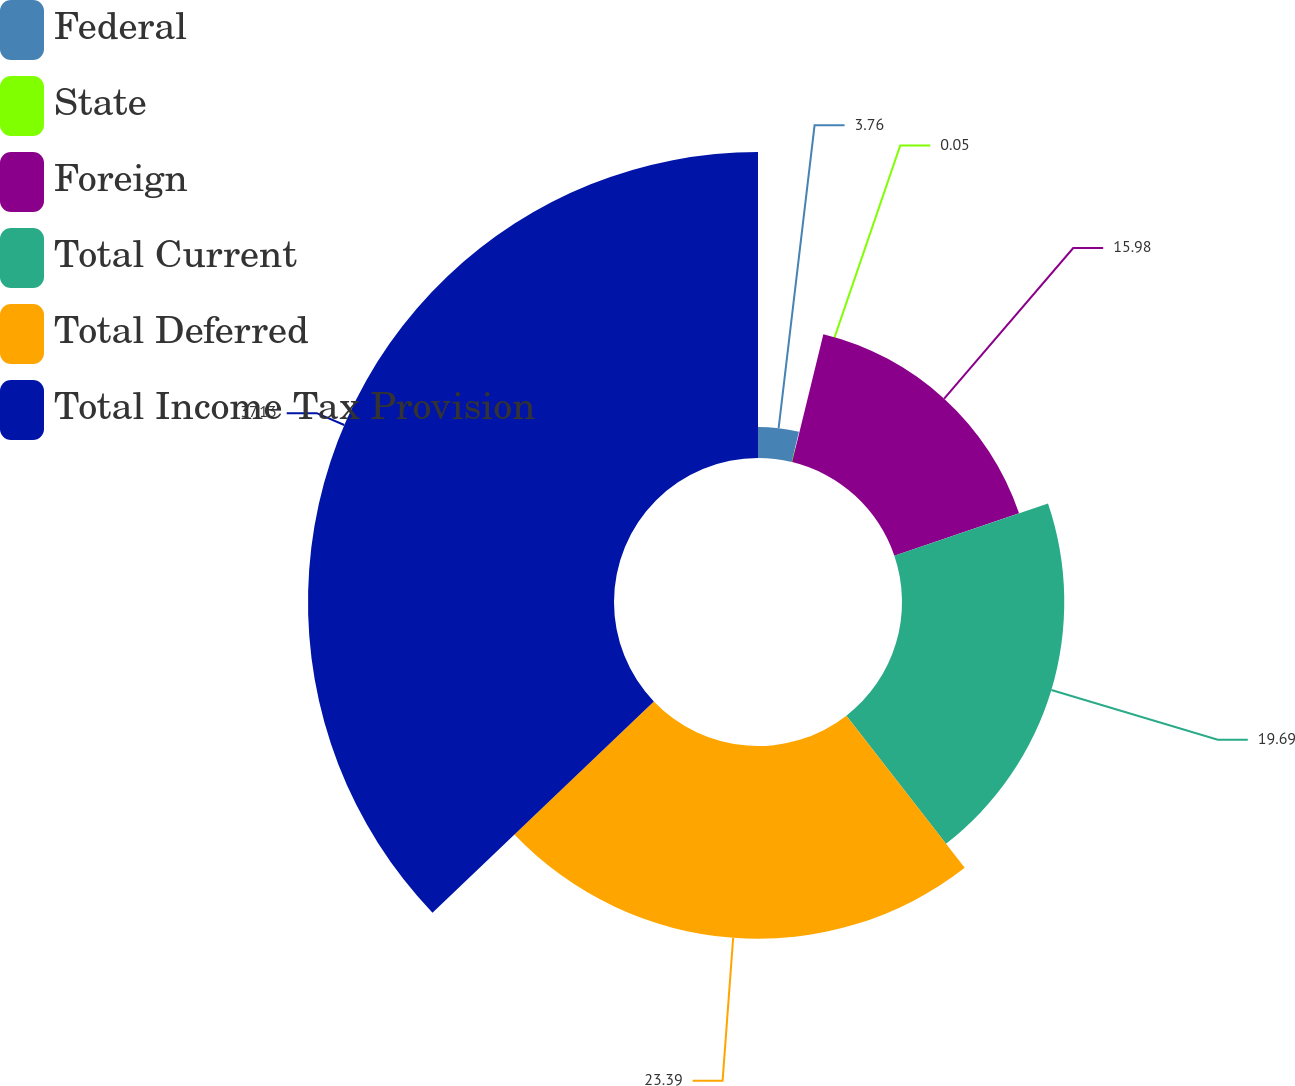Convert chart. <chart><loc_0><loc_0><loc_500><loc_500><pie_chart><fcel>Federal<fcel>State<fcel>Foreign<fcel>Total Current<fcel>Total Deferred<fcel>Total Income Tax Provision<nl><fcel>3.76%<fcel>0.05%<fcel>15.98%<fcel>19.69%<fcel>23.39%<fcel>37.13%<nl></chart> 